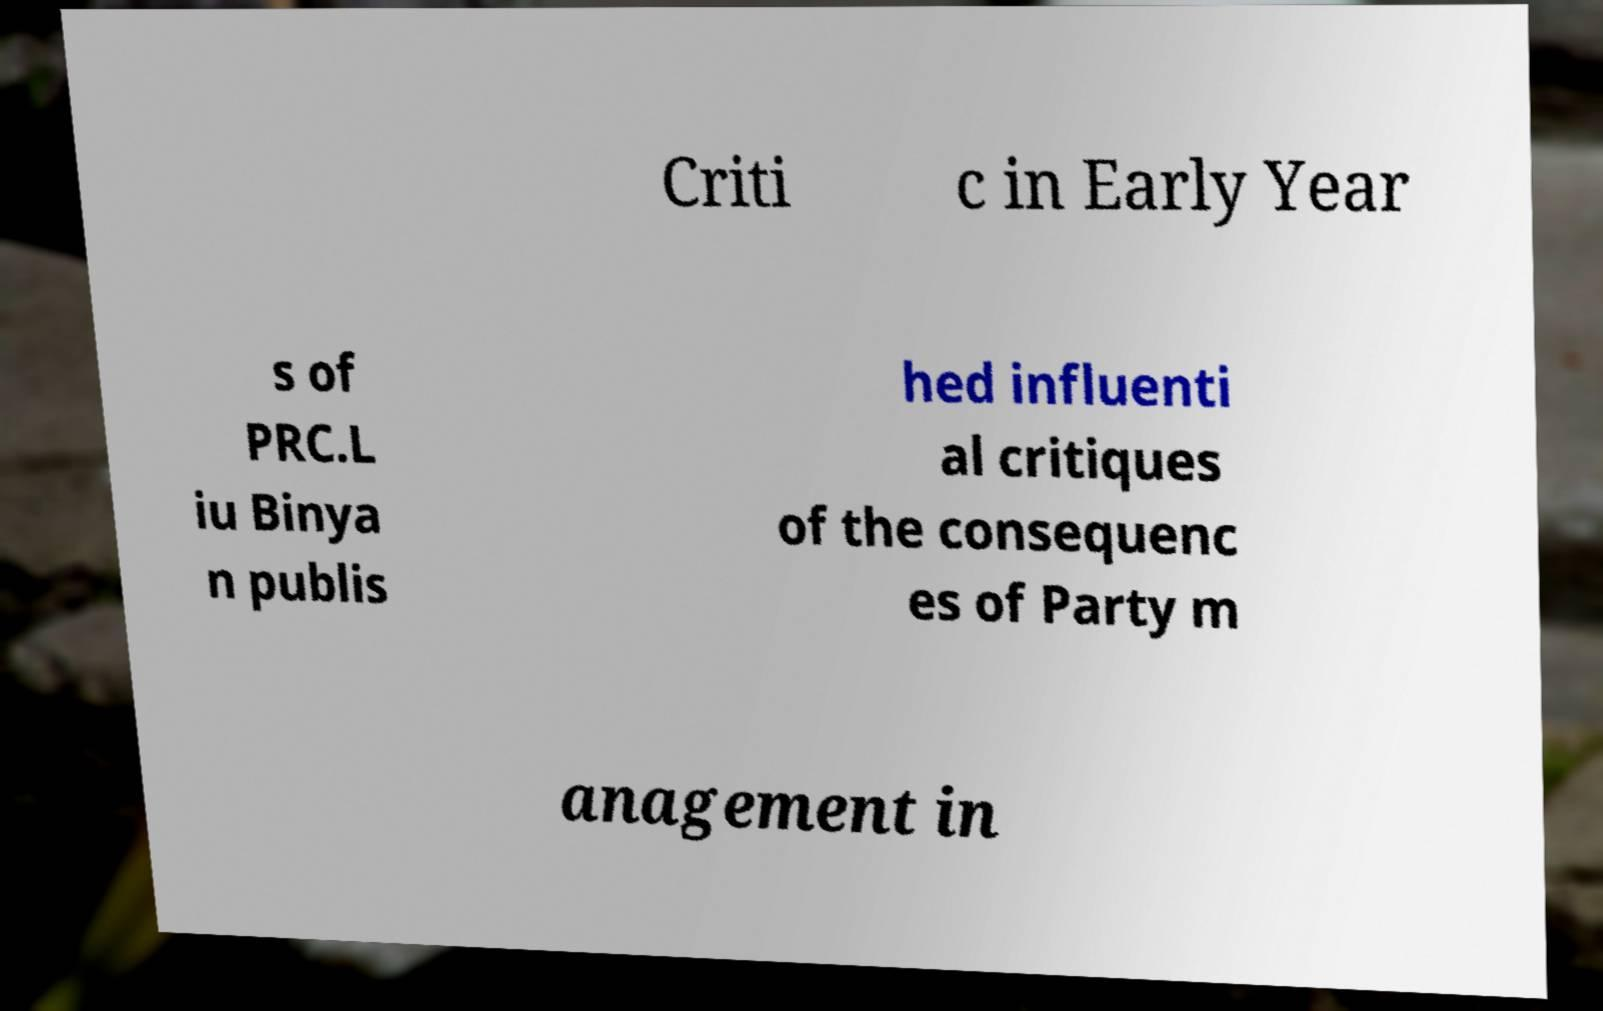There's text embedded in this image that I need extracted. Can you transcribe it verbatim? Criti c in Early Year s of PRC.L iu Binya n publis hed influenti al critiques of the consequenc es of Party m anagement in 